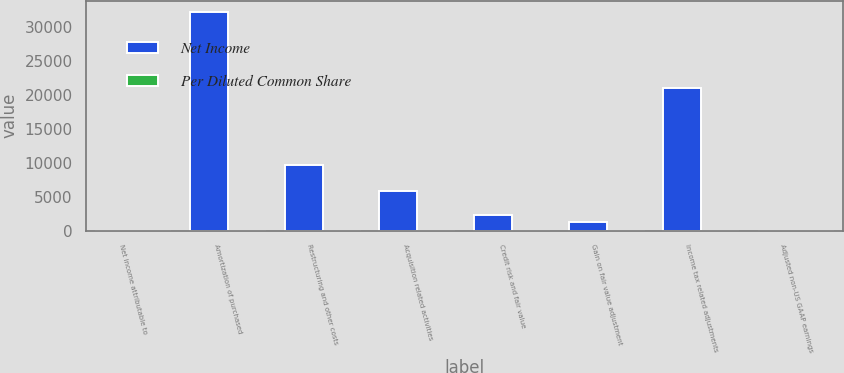<chart> <loc_0><loc_0><loc_500><loc_500><stacked_bar_chart><ecel><fcel>Net income attributable to<fcel>Amortization of purchased<fcel>Restructuring and other costs<fcel>Acquisition related activities<fcel>Credit risk and fair value<fcel>Gain on fair value adjustment<fcel>Income tax related adjustments<fcel>Adjusted non-US GAAP earnings<nl><fcel>Net Income<fcel>2.255<fcel>32309<fcel>9721<fcel>5890<fcel>2339<fcel>1200<fcel>21054<fcel>2.255<nl><fcel>Per Diluted Common Share<fcel>2.16<fcel>0.22<fcel>0.07<fcel>0.04<fcel>0.02<fcel>0.01<fcel>0.15<fcel>2.35<nl></chart> 